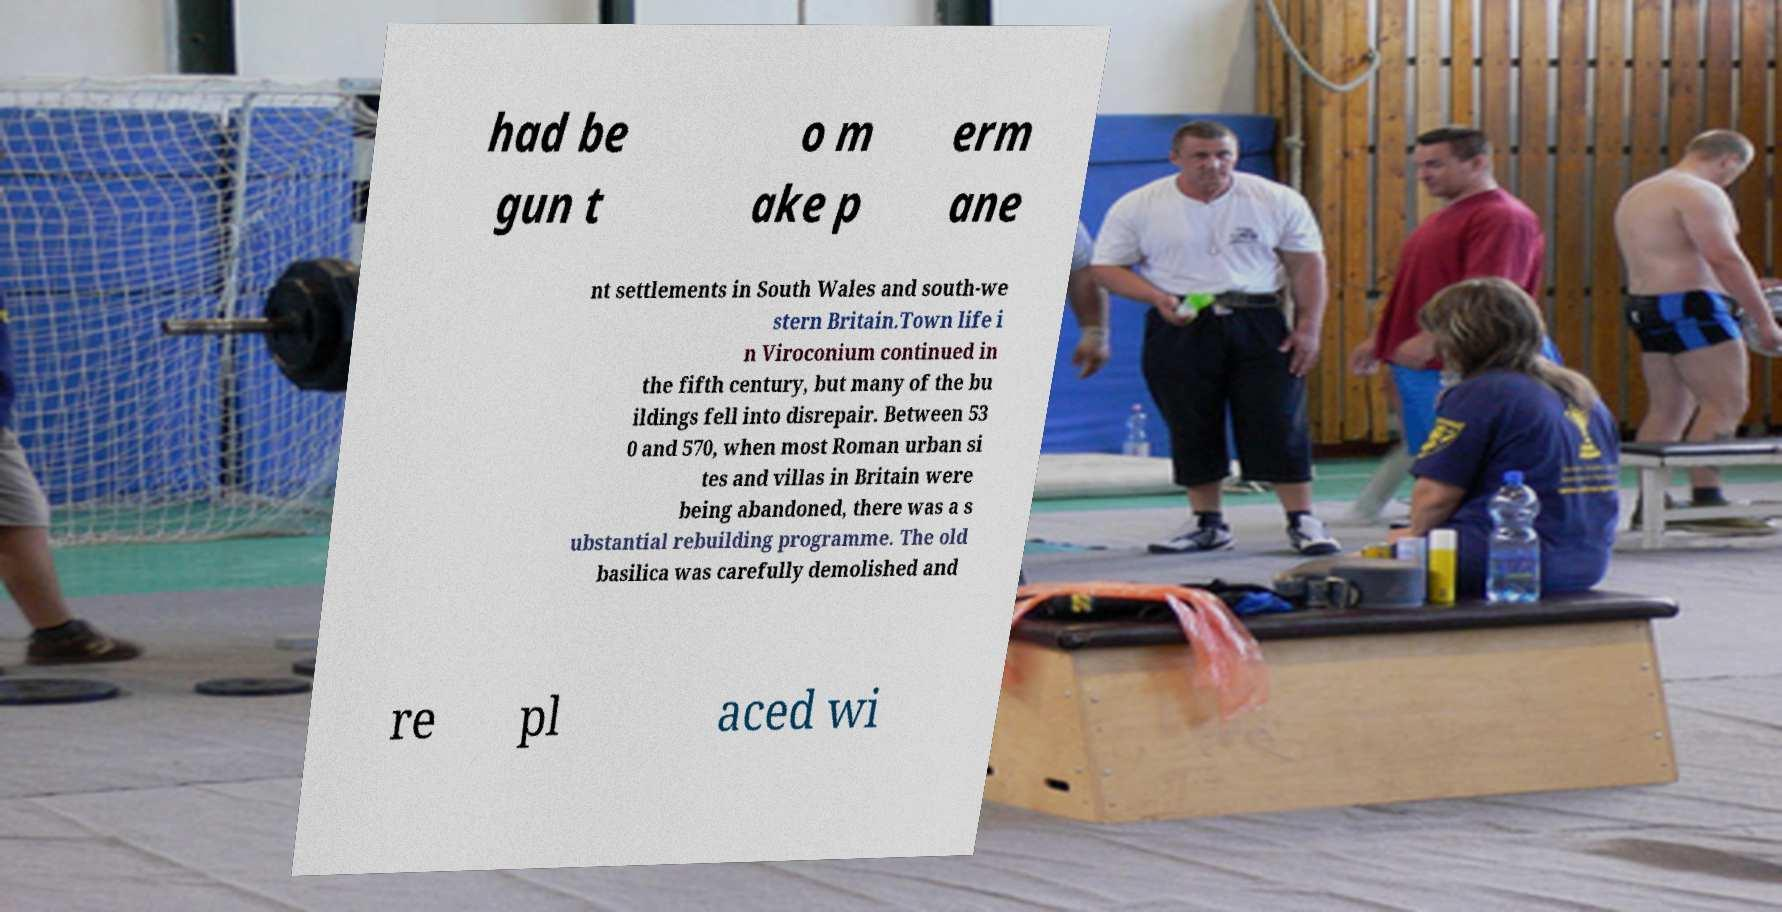Could you assist in decoding the text presented in this image and type it out clearly? had be gun t o m ake p erm ane nt settlements in South Wales and south-we stern Britain.Town life i n Viroconium continued in the fifth century, but many of the bu ildings fell into disrepair. Between 53 0 and 570, when most Roman urban si tes and villas in Britain were being abandoned, there was a s ubstantial rebuilding programme. The old basilica was carefully demolished and re pl aced wi 